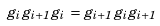Convert formula to latex. <formula><loc_0><loc_0><loc_500><loc_500>g _ { i } \, g _ { i + 1 } \, g _ { i } \, = \, g _ { i + 1 } \, g _ { i } \, g _ { i + 1 }</formula> 